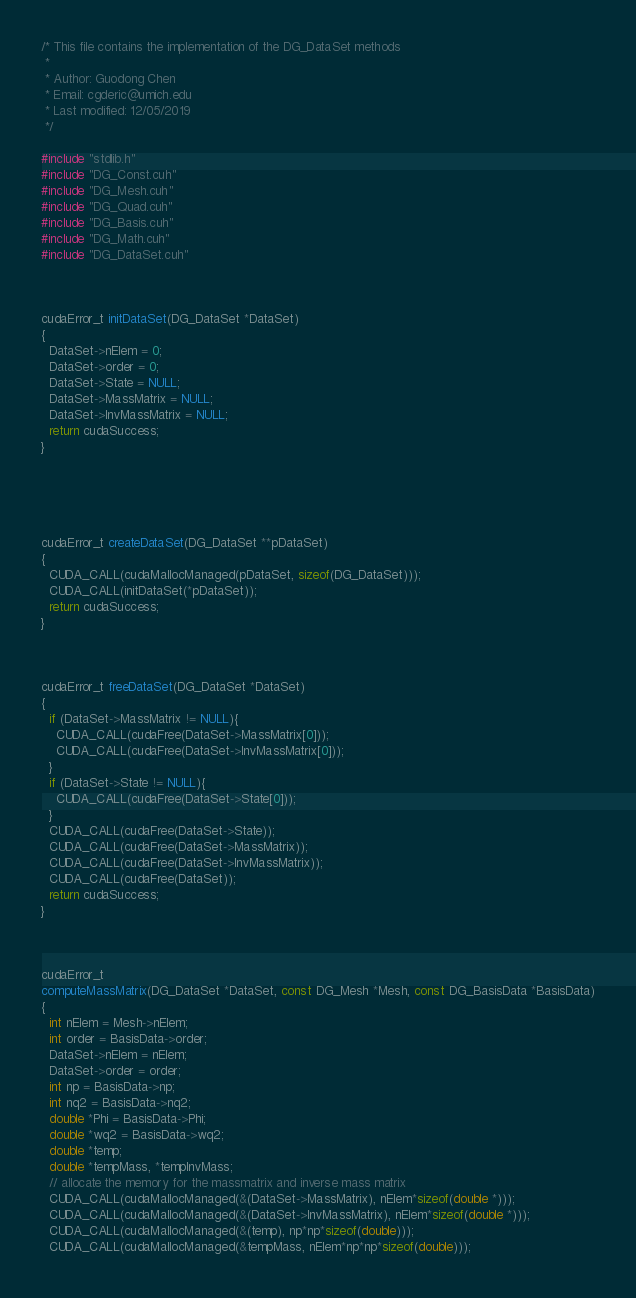Convert code to text. <code><loc_0><loc_0><loc_500><loc_500><_Cuda_>/* This file contains the implementation of the DG_DataSet methods 
 *
 * Author: Guodong Chen
 * Email: cgderic@umich.edu 
 * Last modified: 12/05/2019
 */ 

#include "stdlib.h"
#include "DG_Const.cuh"
#include "DG_Mesh.cuh"
#include "DG_Quad.cuh"
#include "DG_Basis.cuh"
#include "DG_Math.cuh"
#include "DG_DataSet.cuh"



cudaError_t initDataSet(DG_DataSet *DataSet)
{
  DataSet->nElem = 0;
  DataSet->order = 0;
  DataSet->State = NULL;
  DataSet->MassMatrix = NULL;
  DataSet->InvMassMatrix = NULL; 
  return cudaSuccess; 
}





cudaError_t createDataSet(DG_DataSet **pDataSet)
{
  CUDA_CALL(cudaMallocManaged(pDataSet, sizeof(DG_DataSet))); 
  CUDA_CALL(initDataSet(*pDataSet));
  return cudaSuccess; 
}



cudaError_t freeDataSet(DG_DataSet *DataSet)
{
  if (DataSet->MassMatrix != NULL){
    CUDA_CALL(cudaFree(DataSet->MassMatrix[0])); 
    CUDA_CALL(cudaFree(DataSet->InvMassMatrix[0]));
  }
  if (DataSet->State != NULL){
    CUDA_CALL(cudaFree(DataSet->State[0]));
  }
  CUDA_CALL(cudaFree(DataSet->State));  
  CUDA_CALL(cudaFree(DataSet->MassMatrix));  
  CUDA_CALL(cudaFree(DataSet->InvMassMatrix));
  CUDA_CALL(cudaFree(DataSet));
  return cudaSuccess; 
}



cudaError_t
computeMassMatrix(DG_DataSet *DataSet, const DG_Mesh *Mesh, const DG_BasisData *BasisData)
{
  int nElem = Mesh->nElem;
  int order = BasisData->order;
  DataSet->nElem = nElem;
  DataSet->order = order; 
  int np = BasisData->np;
  int nq2 = BasisData->nq2; 
  double *Phi = BasisData->Phi; 
  double *wq2 = BasisData->wq2; 
  double *temp; 
  double *tempMass, *tempInvMass; 
  // allocate the memory for the massmatrix and inverse mass matrix 
  CUDA_CALL(cudaMallocManaged(&(DataSet->MassMatrix), nElem*sizeof(double *)));
  CUDA_CALL(cudaMallocManaged(&(DataSet->InvMassMatrix), nElem*sizeof(double *))); 
  CUDA_CALL(cudaMallocManaged(&(temp), np*np*sizeof(double))); 
  CUDA_CALL(cudaMallocManaged(&tempMass, nElem*np*np*sizeof(double)));</code> 